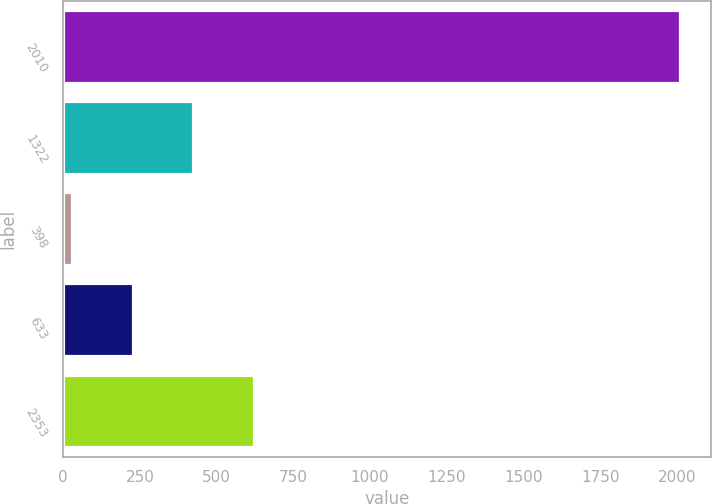Convert chart to OTSL. <chart><loc_0><loc_0><loc_500><loc_500><bar_chart><fcel>2010<fcel>1322<fcel>398<fcel>633<fcel>2353<nl><fcel>2009<fcel>424.2<fcel>28<fcel>226.1<fcel>622.3<nl></chart> 